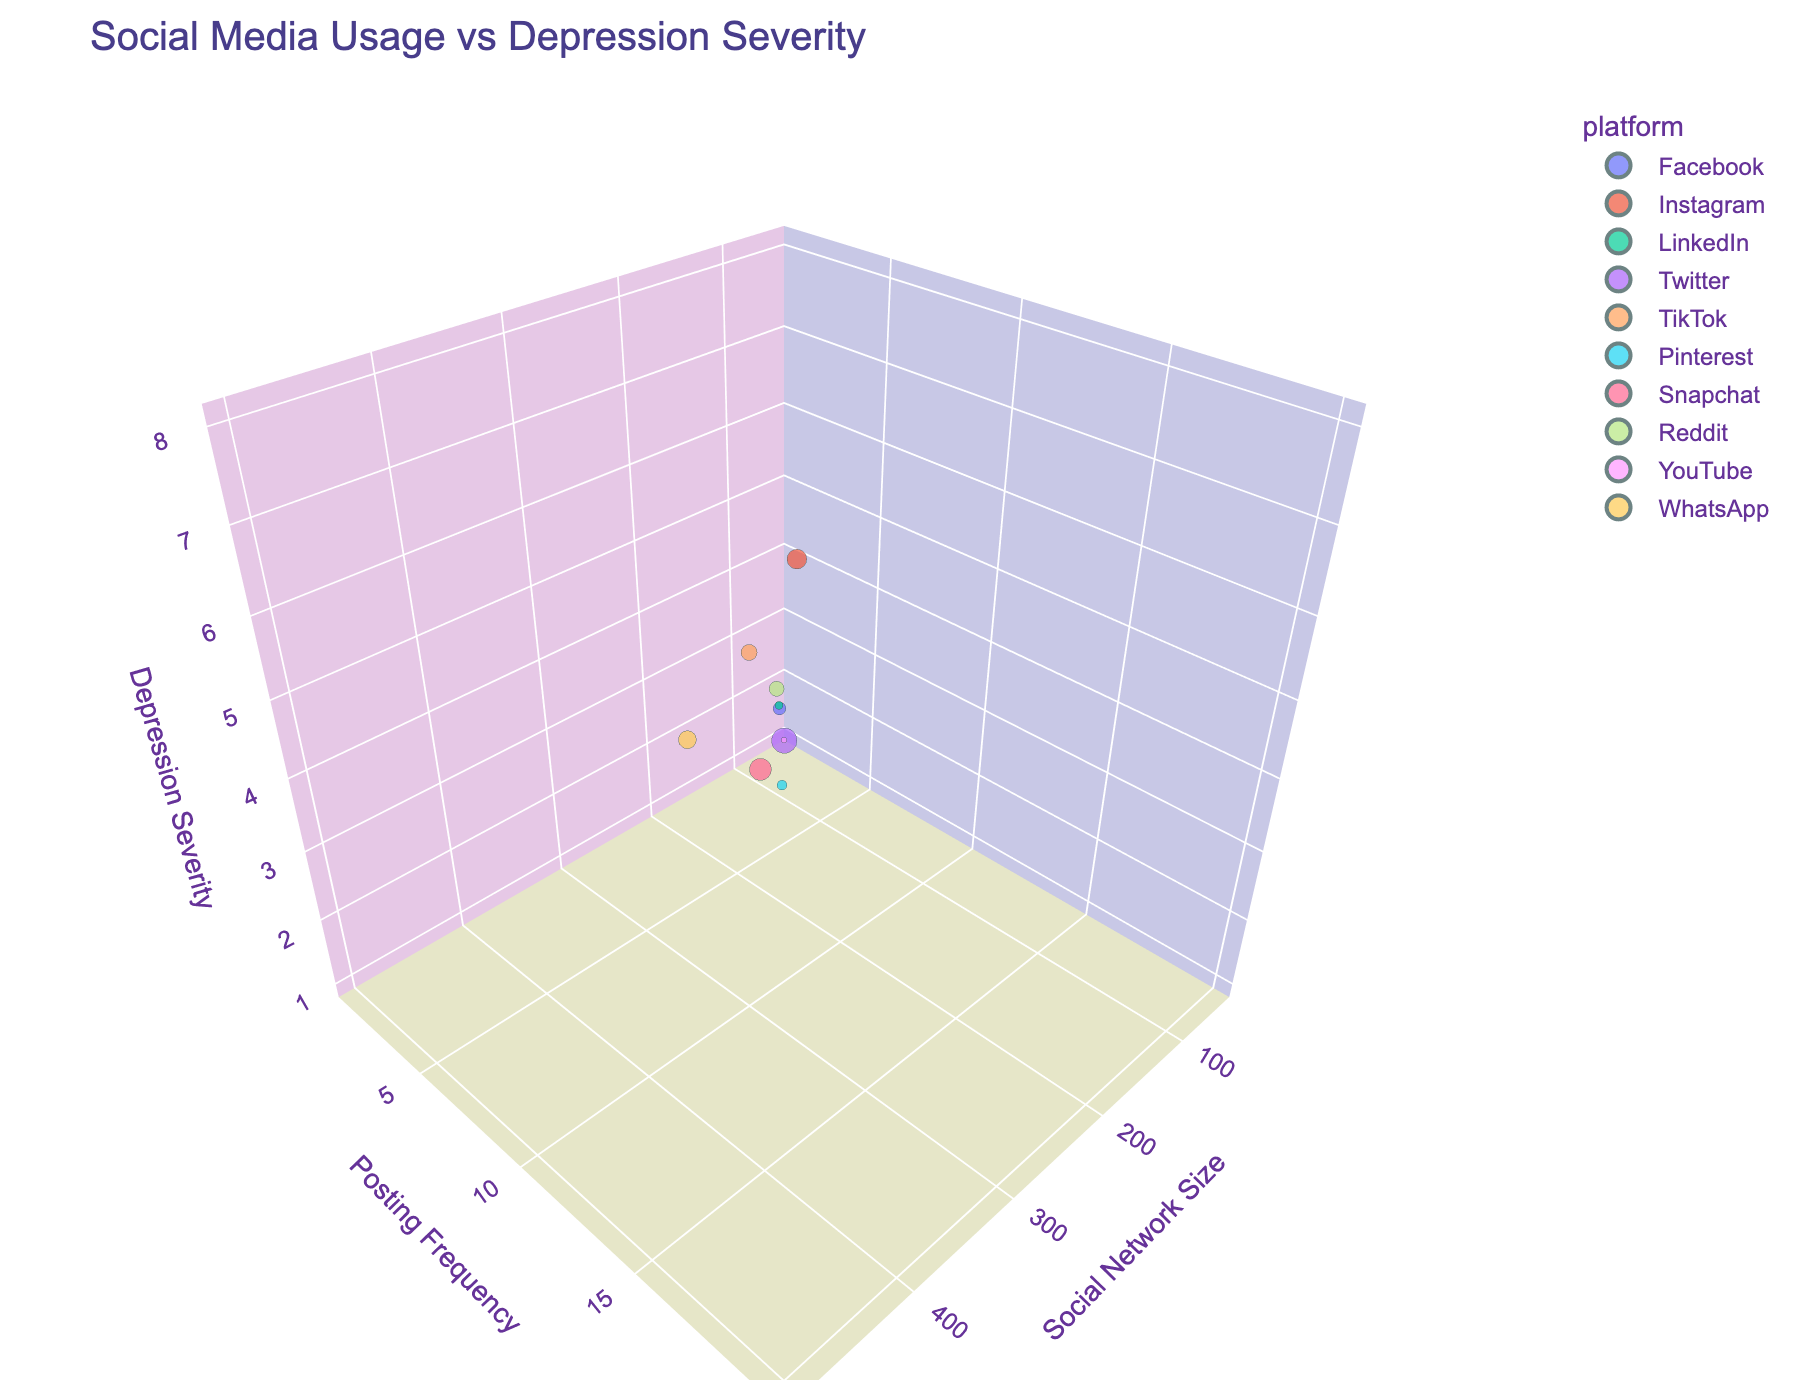What is the title of the figure? The title is usually placed at the top of the chart for quick identification. Look at the top center of the figure.
Answer: Social Media Usage vs Depression Severity What are the labels for the axes? Axe labels describe what each axis represents and are found near the axes themselves. Check near the x, y, and z axes.
Answer: Social Network Size, Posting Frequency, Depression Severity Which platform has the highest posting frequency? Identify the bubble with the largest size (indicating highest posting frequency) and note its color/hover text.
Answer: Twitter How many platforms are shown in the figure? Count the distinct platforms listed when hovering over each bubble or look at how many unique colors are used in the plot.
Answer: 10 What is the correlation between social network size and depression severity for the platforms? Analyze the general trend of the bubbles' positions relative to the x-axis (social network size) and z-axis (depression severity).
Answer: Higher social network size tends to relate to higher depression severity Which platform has the lowest depression severity? Look for the bubble with the smallest value on the z-axis (depression severity) and identify its associated platform.
Answer: Pinterest and YouTube Compare the social network size and posting frequency of Instagram and Snapchat. Which platform has a larger social network size, and which has a higher posting frequency? Find the bubbles for Instagram and Snapchat. Compare their positions on the x-axis (social network size) and the bubble size (posting frequency).
Answer: Instagram has a larger social network size, Snapchat has a higher posting frequency What is the average social network size of Pinterest and LinkedIn? Locate the bubbles for Pinterest and LinkedIn, note their x-values (social network size), and calculate the average: (Social network size of Pinterest + Social network size of LinkedIn) / 2.
Answer: (100 + 80) / 2 = 90 Is there a platform with both low posting frequency and low social network size? Identify bubbles with smaller sizes (indicating low posting frequency) and lower x-values (low social network size).
Answer: YouTube and LinkedIn What relationship can be observed between posting frequency and depression severity? Look for the trend between the y-axis (posting frequency) and z-axis (depression severity) by analyzing how bubble sizes and their heights correspond.
Answer: Higher posting frequency often corresponds to higher depression severity 